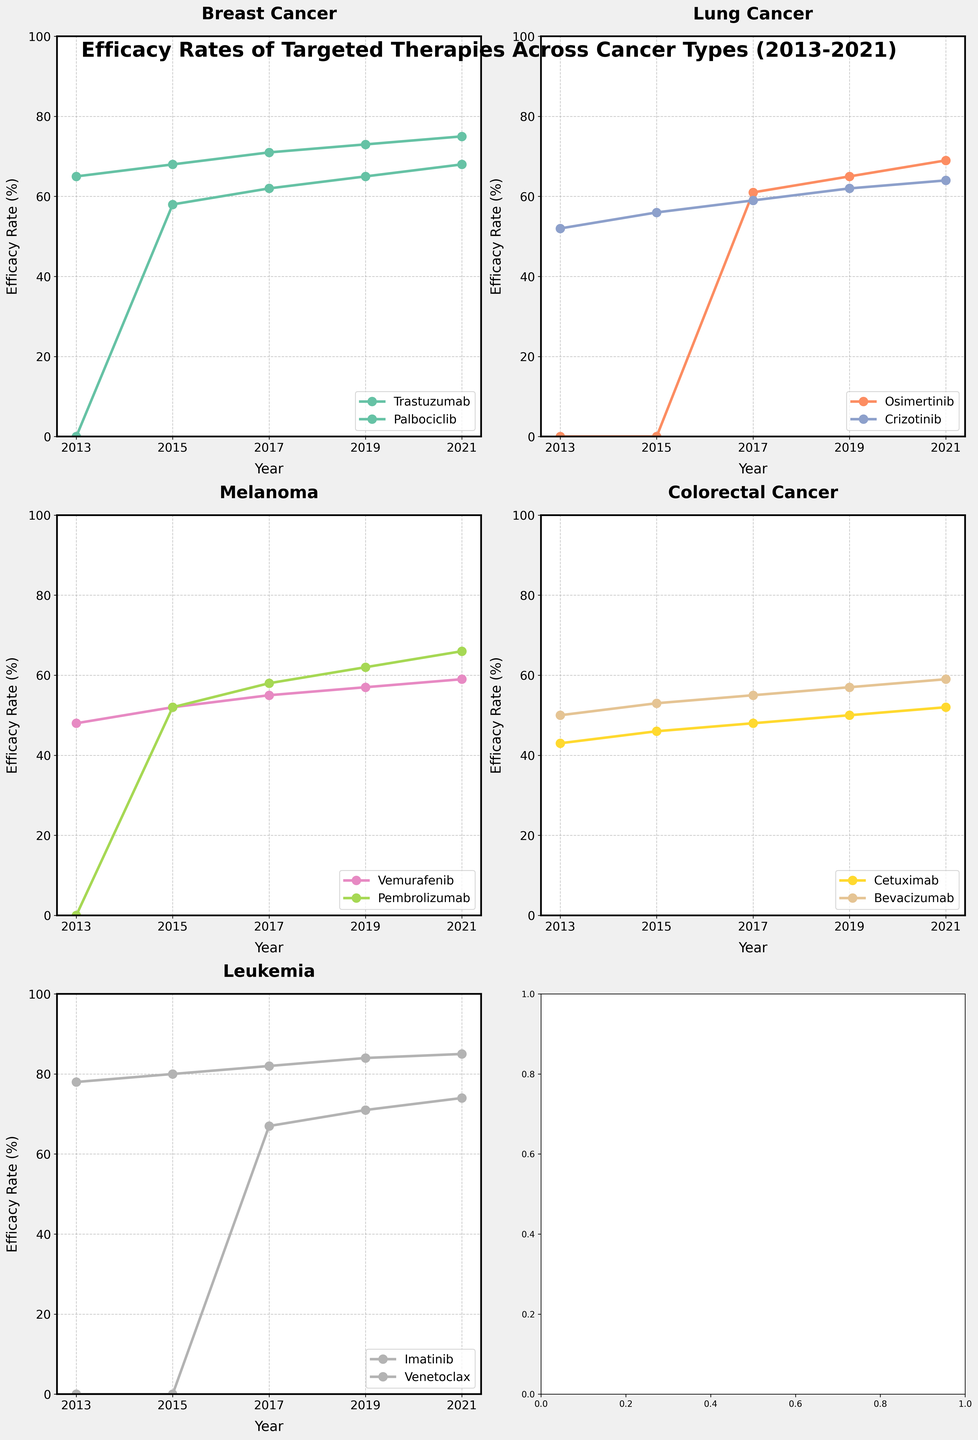What is the title of the figure? The title of the figure is located at the top and is usually larger and bolder compared to other text. In this figure, it reads: "Efficacy Rates of Targeted Therapies Across Cancer Types (2013-2021)".
Answer: Efficacy Rates of Targeted Therapies Across Cancer Types (2013-2021) How many therapies are shown for Breast Cancer? Breast Cancer has two different therapies plotted. By looking at the subplot titled "Breast Cancer," there are two lines, each representing a therapy.
Answer: 2 Which therapy shows the highest efficacy rate in 2015 for Leukemia? In the subplot for Leukemia, two therapies are shown: Imatinib and Venetoclax. Look at the efficacy rate for 2015 and compare the values. Imatinib shows a rate of 80% in 2015, higher than Venetoclax.
Answer: Imatinib In which year did Palbociclib start showing efficacy for Breast Cancer? The subplot for Breast Cancer has a line for Palbociclib, which starts at 0% in 2013 but shows efficacy in subsequent years. The first non-zero value appears in 2015.
Answer: 2015 Compare the efficacy of Osimertinib and Crizotinib in 2019 for Lung Cancer. Which one is higher? In the subplot for Lung Cancer, Osimertinib shows an efficacy rate of 65% in 2019, while Crizotinib shows a rate of 62%. Therefore, Osimertinib is higher.
Answer: Osimertinib What is the average efficacy rate of Vemurafenib for Melanoma from 2013 to 2021? For Vemurafenib, the efficacy rates from 2013 to 2021 are 48%, 52%, 55%, 57%, and 59%. Calculate the average by summing these values and dividing by the count: (48 + 52 + 55 + 57 + 59) / 5. The result is 54.2%.
Answer: 54.2% Which cancer type has the therapy with the highest efficacy rate in 2021? By comparing the efficacy rates in the 2021 column of each subplot, Leukemia with Imatinib has the highest rate of 85%.
Answer: Leukemia Between Cetuximab and Bevacizumab for Colorectal Cancer, which therapy has consistently higher efficacy rates from 2013 to 2021? Look at both lines in the Colorectal Cancer subplot. Bevacizumab consistently maintains higher efficacy rates compared to Cetuximab in all years.
Answer: Bevacizumab What is the difference in efficacy rates of Pembrolizumab for Melanoma between 2015 and 2021? Refer to the subplot for Melanoma. For Pembrolizumab, the efficacy rate in 2015 is 52% and in 2021 is 66%. The difference is calculated as 66% - 52%.
Answer: 14% In which year did Venetoclax show the greatest increase in efficacy for Leukemia? For Venetoclax in the Leukemia subplot, compare the increases year-over-year. The largest increase is from 0% in 2015 to 67% in 2017, showing a 67% increase, which is the greatest.
Answer: 2017 